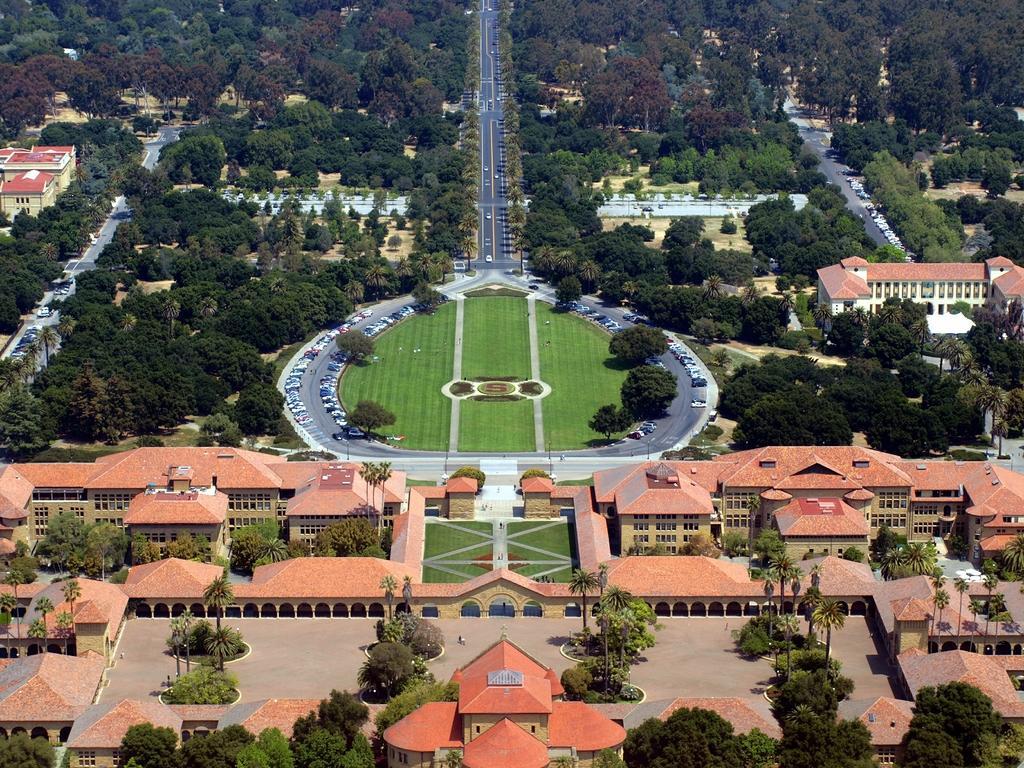In one or two sentences, can you explain what this image depicts? In this image I see the buildings, green grass and I see grass over here too and I see number of trees and I see the road. 